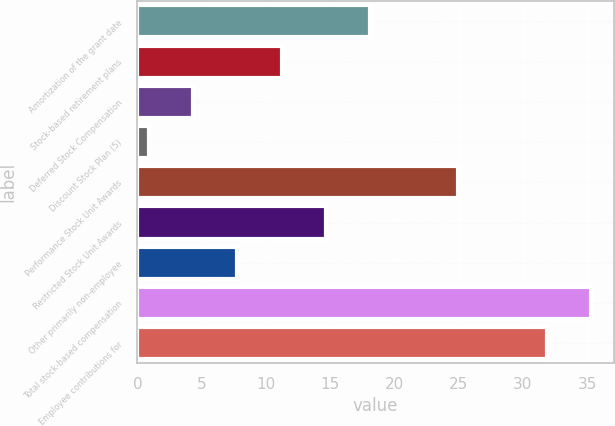Convert chart to OTSL. <chart><loc_0><loc_0><loc_500><loc_500><bar_chart><fcel>Amortization of the grant date<fcel>Stock-based retirement plans<fcel>Deferred Stock Compensation<fcel>Discount Stock Plan (5)<fcel>Performance Stock Unit Awards<fcel>Restricted Stock Unit Awards<fcel>Other primarily non-employee<fcel>Total stock-based compensation<fcel>Employee contributions for<nl><fcel>18.1<fcel>11.22<fcel>4.34<fcel>0.9<fcel>24.98<fcel>14.66<fcel>7.78<fcel>35.3<fcel>31.86<nl></chart> 